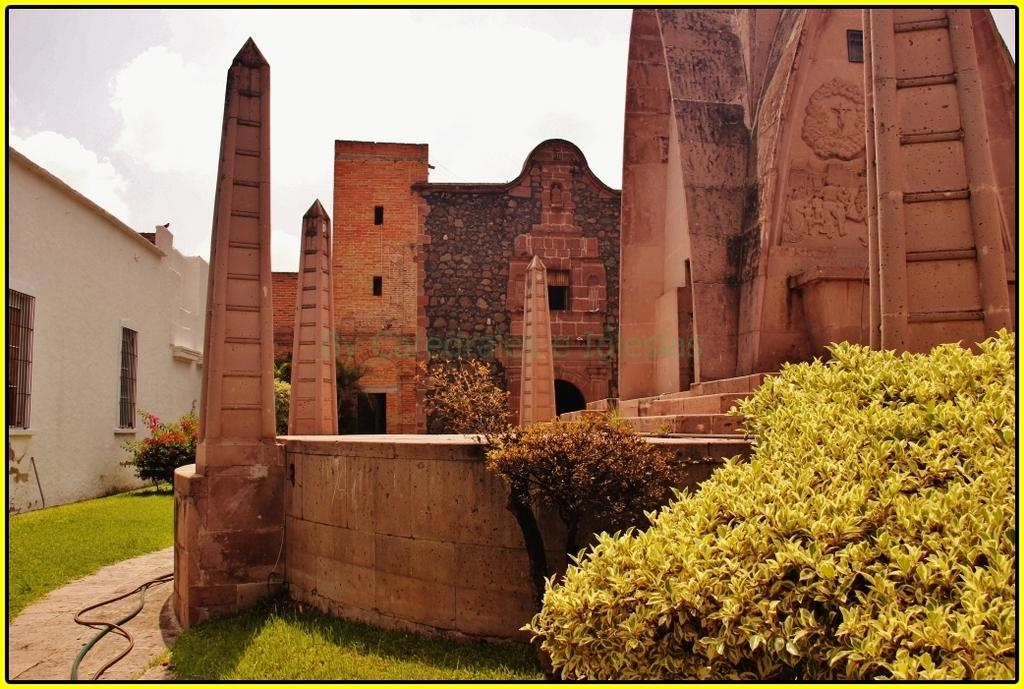What type of structure is depicted in the image? There is a building with towers in the image. What are some features of the building? The building has windows. What can be seen on the right side of the image? There is a group of plants on the right side of the image. What is visible in the background of the image? The sky is visible in the background of the image. How many bananas are hanging from the building in the image? There are no bananas present in the image; it features a building with towers, windows, plants, and a visible sky. 